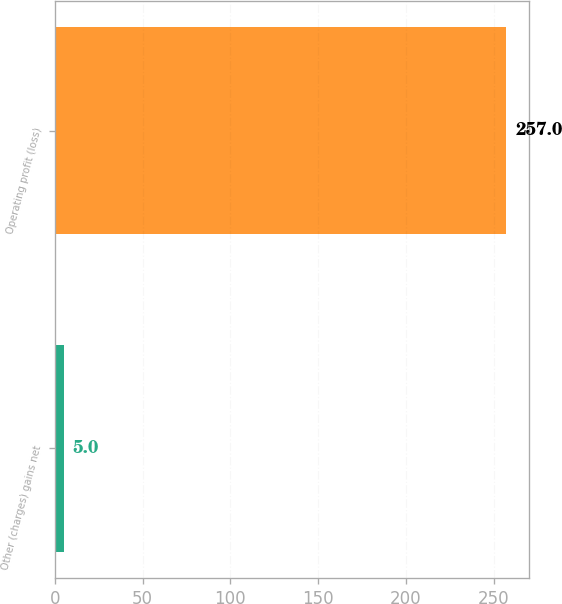Convert chart. <chart><loc_0><loc_0><loc_500><loc_500><bar_chart><fcel>Other (charges) gains net<fcel>Operating profit (loss)<nl><fcel>5<fcel>257<nl></chart> 